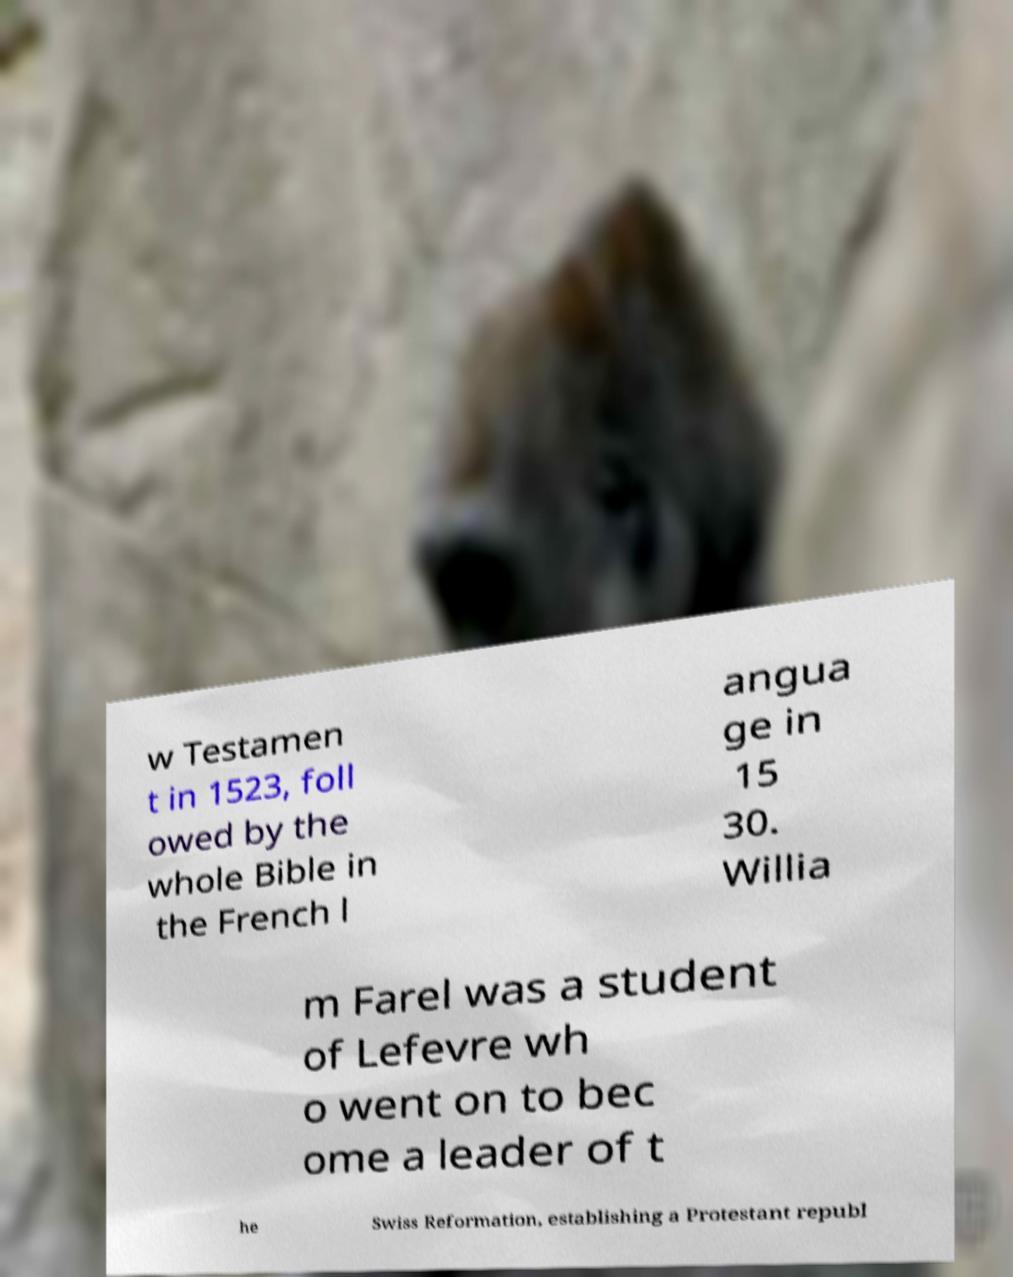Could you extract and type out the text from this image? w Testamen t in 1523, foll owed by the whole Bible in the French l angua ge in 15 30. Willia m Farel was a student of Lefevre wh o went on to bec ome a leader of t he Swiss Reformation, establishing a Protestant republ 